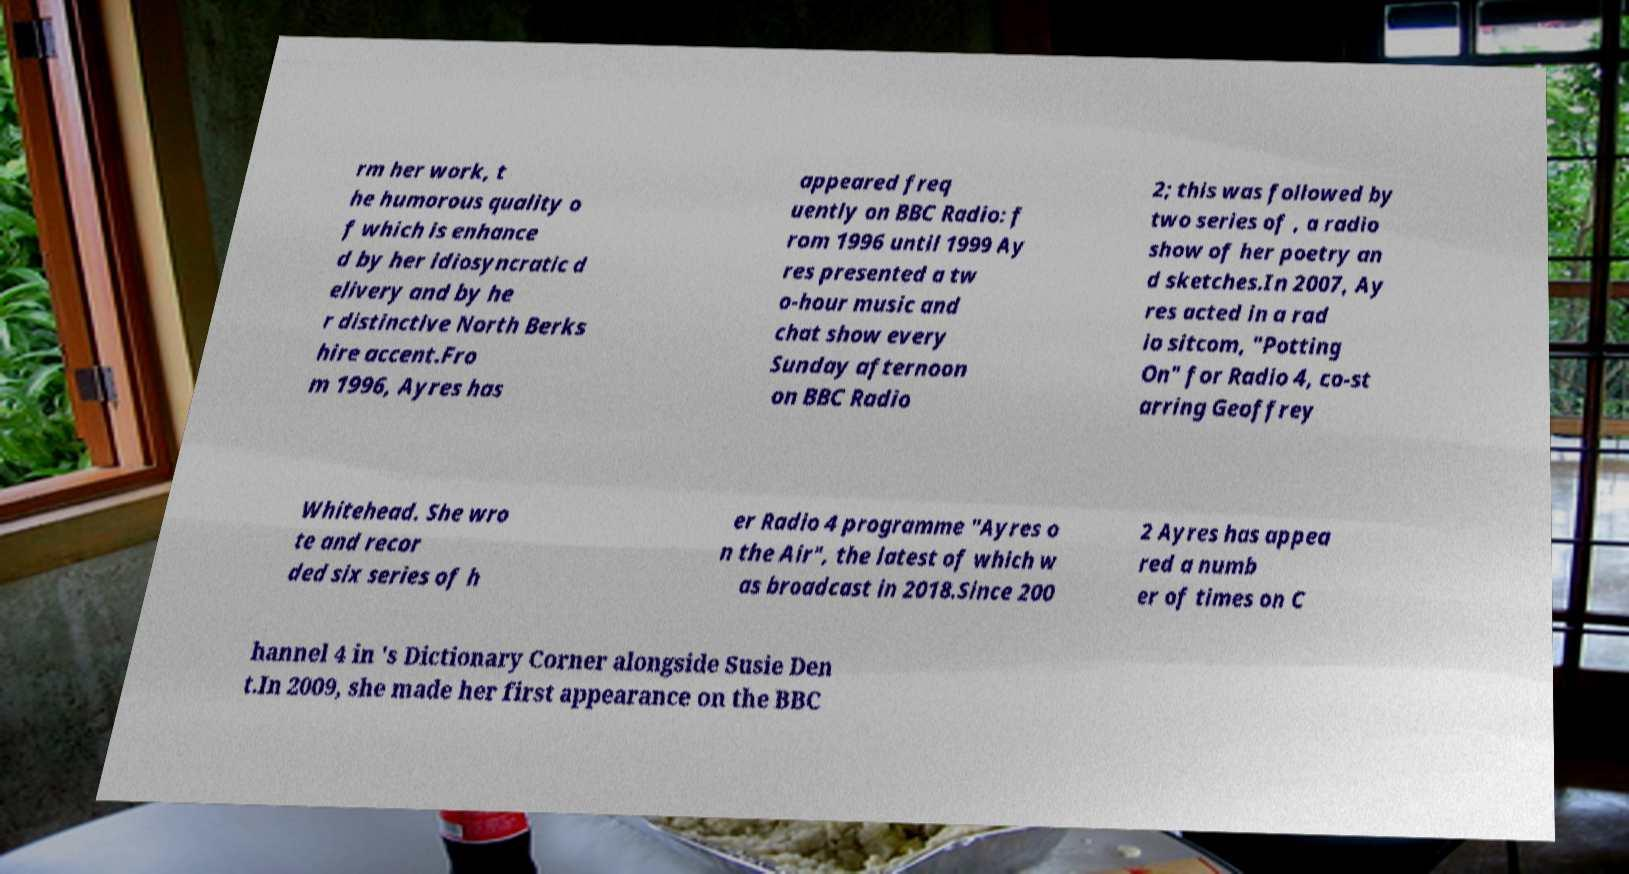Can you accurately transcribe the text from the provided image for me? rm her work, t he humorous quality o f which is enhance d by her idiosyncratic d elivery and by he r distinctive North Berks hire accent.Fro m 1996, Ayres has appeared freq uently on BBC Radio: f rom 1996 until 1999 Ay res presented a tw o-hour music and chat show every Sunday afternoon on BBC Radio 2; this was followed by two series of , a radio show of her poetry an d sketches.In 2007, Ay res acted in a rad io sitcom, "Potting On" for Radio 4, co-st arring Geoffrey Whitehead. She wro te and recor ded six series of h er Radio 4 programme "Ayres o n the Air", the latest of which w as broadcast in 2018.Since 200 2 Ayres has appea red a numb er of times on C hannel 4 in 's Dictionary Corner alongside Susie Den t.In 2009, she made her first appearance on the BBC 